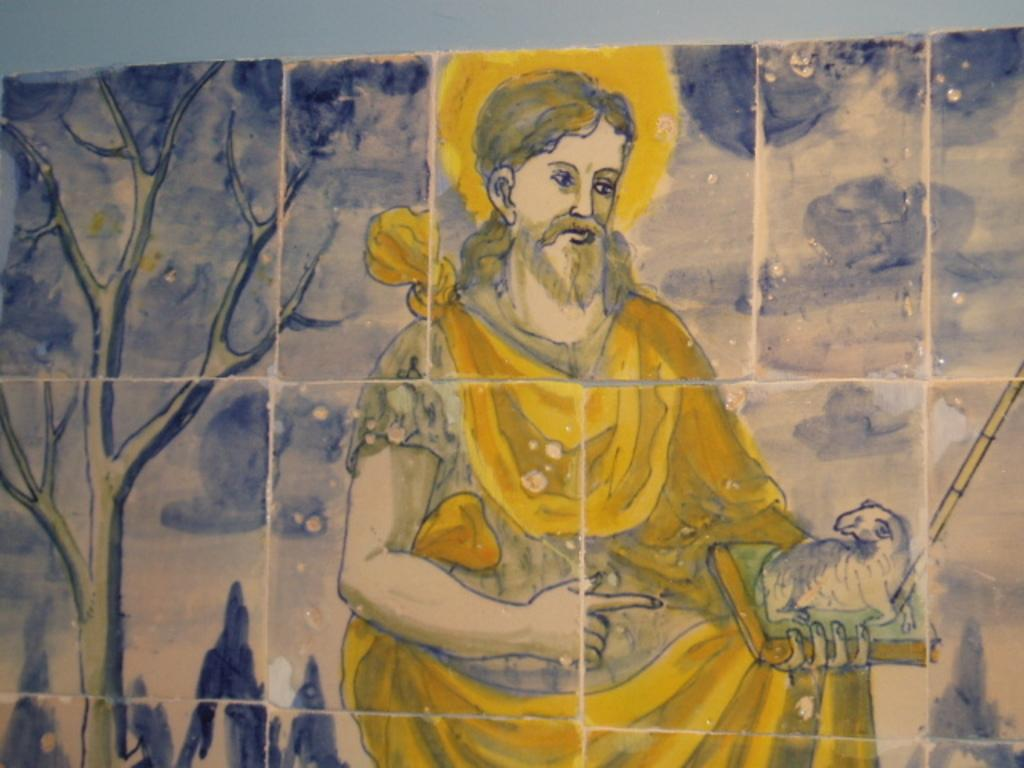What is depicted in the painting in the image? There is a painting of a man in the image. What is the man in the painting holding? The man in the painting is holding a book. What type of plant can be seen in the image? There is a tree in the image. What is present on the wall in the image? There is a photo frame on the wall in the image. What type of lunchroom is shown in the painting? The painting does not depict a lunchroom; it is a painting of a man holding a book. What is the profit of the organization in the image? There is no mention of an organization or profit in the image; it features a painting of a man holding a book, a tree, and a photo frame on the wall. 